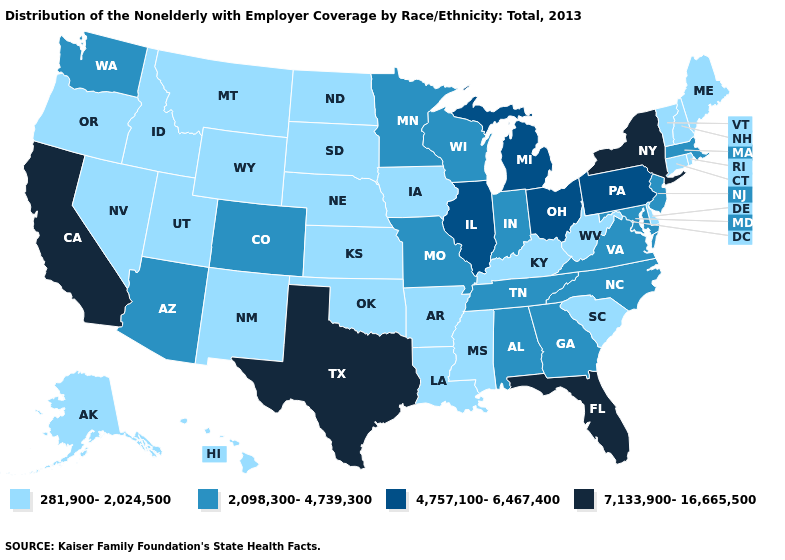Which states have the lowest value in the MidWest?
Write a very short answer. Iowa, Kansas, Nebraska, North Dakota, South Dakota. What is the value of New Hampshire?
Keep it brief. 281,900-2,024,500. Is the legend a continuous bar?
Keep it brief. No. Does Texas have the highest value in the USA?
Be succinct. Yes. Name the states that have a value in the range 7,133,900-16,665,500?
Quick response, please. California, Florida, New York, Texas. What is the lowest value in states that border Colorado?
Be succinct. 281,900-2,024,500. Does Rhode Island have the highest value in the Northeast?
Short answer required. No. Name the states that have a value in the range 4,757,100-6,467,400?
Short answer required. Illinois, Michigan, Ohio, Pennsylvania. Name the states that have a value in the range 4,757,100-6,467,400?
Answer briefly. Illinois, Michigan, Ohio, Pennsylvania. Which states have the lowest value in the USA?
Give a very brief answer. Alaska, Arkansas, Connecticut, Delaware, Hawaii, Idaho, Iowa, Kansas, Kentucky, Louisiana, Maine, Mississippi, Montana, Nebraska, Nevada, New Hampshire, New Mexico, North Dakota, Oklahoma, Oregon, Rhode Island, South Carolina, South Dakota, Utah, Vermont, West Virginia, Wyoming. Among the states that border Oklahoma , does Missouri have the highest value?
Quick response, please. No. Among the states that border Nebraska , which have the lowest value?
Quick response, please. Iowa, Kansas, South Dakota, Wyoming. What is the value of Oregon?
Short answer required. 281,900-2,024,500. Does the first symbol in the legend represent the smallest category?
Short answer required. Yes. 